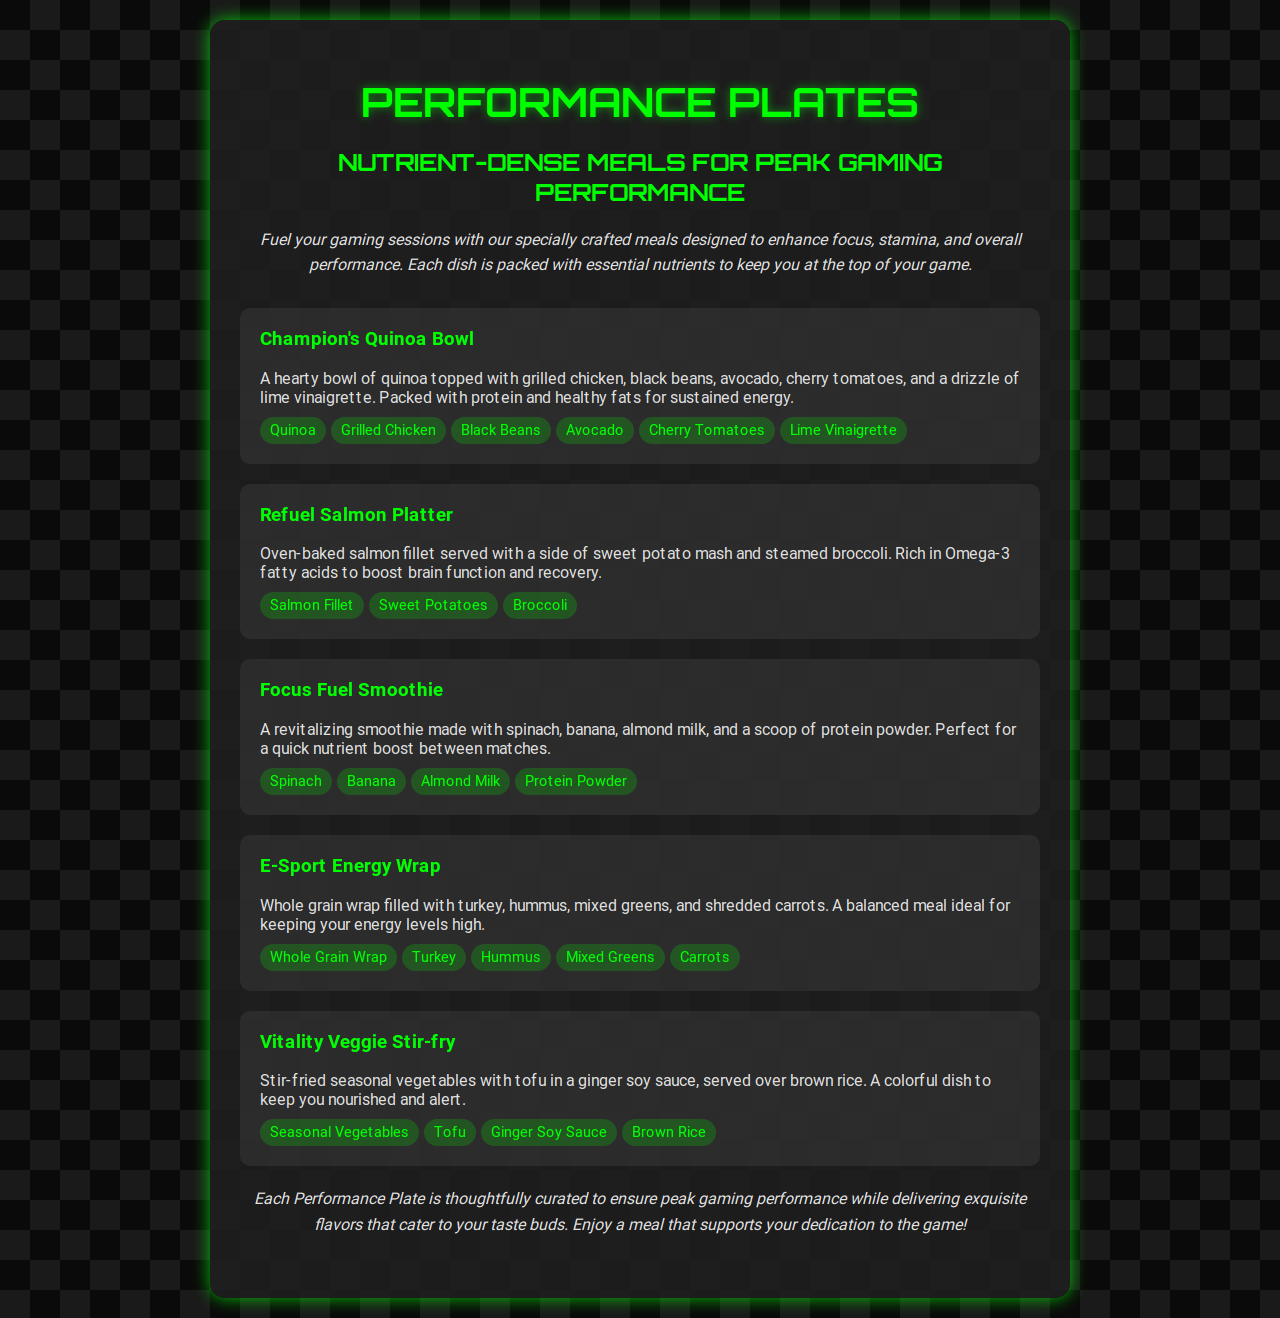What is the title of the menu? The title is the name given to the entire menu document that summarizes its content and purpose.
Answer: Performance Plates How many items are listed on the menu? The number of items refers to the distinct meals presented within the menu.
Answer: Five What is included in the Champion's Quinoa Bowl? This question seeks to identify specific ingredients featured in a particular dish on the menu.
Answer: Quinoa, Grilled Chicken, Black Beans, Avocado, Cherry Tomatoes, Lime Vinaigrette What key nutrient is highlighted in the Refuel Salmon Platter? This question focuses on the health benefits associated with a specific dish.
Answer: Omega-3 fatty acids Which dish is suggested for a quick nutrient boost? This question investigates which item is ideal for a swift energy lift during gaming sessions.
Answer: Focus Fuel Smoothie What type of wrap is used in the E-Sport Energy Wrap? This question targets a specific ingredient in a meal that can define its categorization.
Answer: Whole Grain Wrap Which dish contains tofu? This question requests the identification of a dish with a specific ingredient to accommodate dietary preferences.
Answer: Vitality Veggie Stir-fry What is the color scheme of the menu background? This question seeks to evaluate the aesthetic layout choice of the menu's design.
Answer: Linear gradient with dark shades and green accents What culinary elements does the Vitality Veggie Stir-fry emphasize? This question aims to summarize what features stand out in the ingredients of a particular dish.
Answer: Seasonal Vegetables, Tofu, Ginger Soy Sauce, Brown Rice 